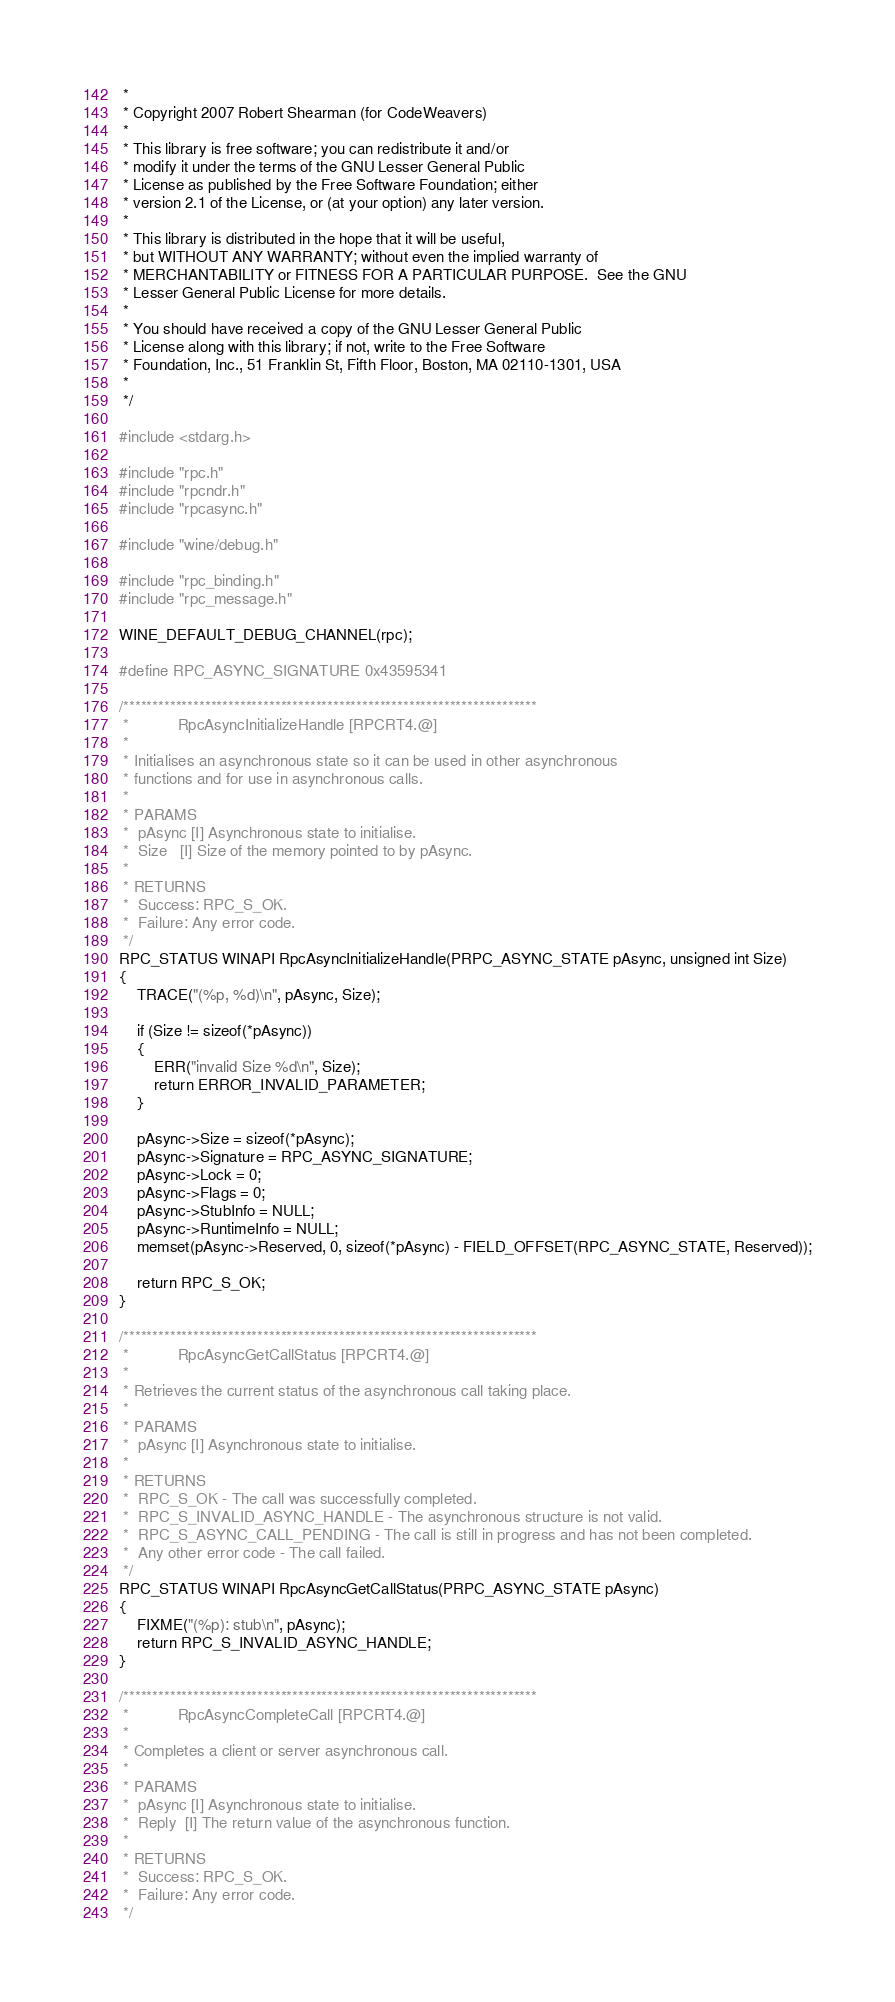Convert code to text. <code><loc_0><loc_0><loc_500><loc_500><_C_> *
 * Copyright 2007 Robert Shearman (for CodeWeavers)
 *
 * This library is free software; you can redistribute it and/or
 * modify it under the terms of the GNU Lesser General Public
 * License as published by the Free Software Foundation; either
 * version 2.1 of the License, or (at your option) any later version.
 *
 * This library is distributed in the hope that it will be useful,
 * but WITHOUT ANY WARRANTY; without even the implied warranty of
 * MERCHANTABILITY or FITNESS FOR A PARTICULAR PURPOSE.  See the GNU
 * Lesser General Public License for more details.
 *
 * You should have received a copy of the GNU Lesser General Public
 * License along with this library; if not, write to the Free Software
 * Foundation, Inc., 51 Franklin St, Fifth Floor, Boston, MA 02110-1301, USA
 *
 */

#include <stdarg.h>

#include "rpc.h"
#include "rpcndr.h"
#include "rpcasync.h"

#include "wine/debug.h"

#include "rpc_binding.h"
#include "rpc_message.h"

WINE_DEFAULT_DEBUG_CHANNEL(rpc);

#define RPC_ASYNC_SIGNATURE 0x43595341

/***********************************************************************
 *           RpcAsyncInitializeHandle [RPCRT4.@]
 *
 * Initialises an asynchronous state so it can be used in other asynchronous
 * functions and for use in asynchronous calls.
 *
 * PARAMS
 *  pAsync [I] Asynchronous state to initialise.
 *  Size   [I] Size of the memory pointed to by pAsync.
 *
 * RETURNS
 *  Success: RPC_S_OK.
 *  Failure: Any error code.
 */
RPC_STATUS WINAPI RpcAsyncInitializeHandle(PRPC_ASYNC_STATE pAsync, unsigned int Size)
{
    TRACE("(%p, %d)\n", pAsync, Size);

    if (Size != sizeof(*pAsync))
    {
        ERR("invalid Size %d\n", Size);
        return ERROR_INVALID_PARAMETER;
    }

    pAsync->Size = sizeof(*pAsync);
    pAsync->Signature = RPC_ASYNC_SIGNATURE;
    pAsync->Lock = 0;
    pAsync->Flags = 0;
    pAsync->StubInfo = NULL;
    pAsync->RuntimeInfo = NULL;
    memset(pAsync->Reserved, 0, sizeof(*pAsync) - FIELD_OFFSET(RPC_ASYNC_STATE, Reserved));

    return RPC_S_OK;
}

/***********************************************************************
 *           RpcAsyncGetCallStatus [RPCRT4.@]
 *
 * Retrieves the current status of the asynchronous call taking place.
 *
 * PARAMS
 *  pAsync [I] Asynchronous state to initialise.
 *
 * RETURNS
 *  RPC_S_OK - The call was successfully completed.
 *  RPC_S_INVALID_ASYNC_HANDLE - The asynchronous structure is not valid.
 *  RPC_S_ASYNC_CALL_PENDING - The call is still in progress and has not been completed.
 *  Any other error code - The call failed.
 */
RPC_STATUS WINAPI RpcAsyncGetCallStatus(PRPC_ASYNC_STATE pAsync)
{
    FIXME("(%p): stub\n", pAsync);
    return RPC_S_INVALID_ASYNC_HANDLE;
}

/***********************************************************************
 *           RpcAsyncCompleteCall [RPCRT4.@]
 *
 * Completes a client or server asynchronous call.
 *
 * PARAMS
 *  pAsync [I] Asynchronous state to initialise.
 *  Reply  [I] The return value of the asynchronous function.
 *
 * RETURNS
 *  Success: RPC_S_OK.
 *  Failure: Any error code.
 */</code> 